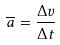<formula> <loc_0><loc_0><loc_500><loc_500>\overline { a } = \frac { \Delta v } { \Delta t }</formula> 